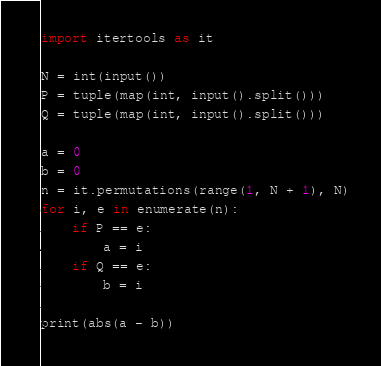Convert code to text. <code><loc_0><loc_0><loc_500><loc_500><_Python_>import itertools as it

N = int(input())
P = tuple(map(int, input().split()))
Q = tuple(map(int, input().split()))

a = 0
b = 0
n = it.permutations(range(1, N + 1), N)
for i, e in enumerate(n):
    if P == e:
        a = i
    if Q == e:
        b = i

print(abs(a - b))
</code> 